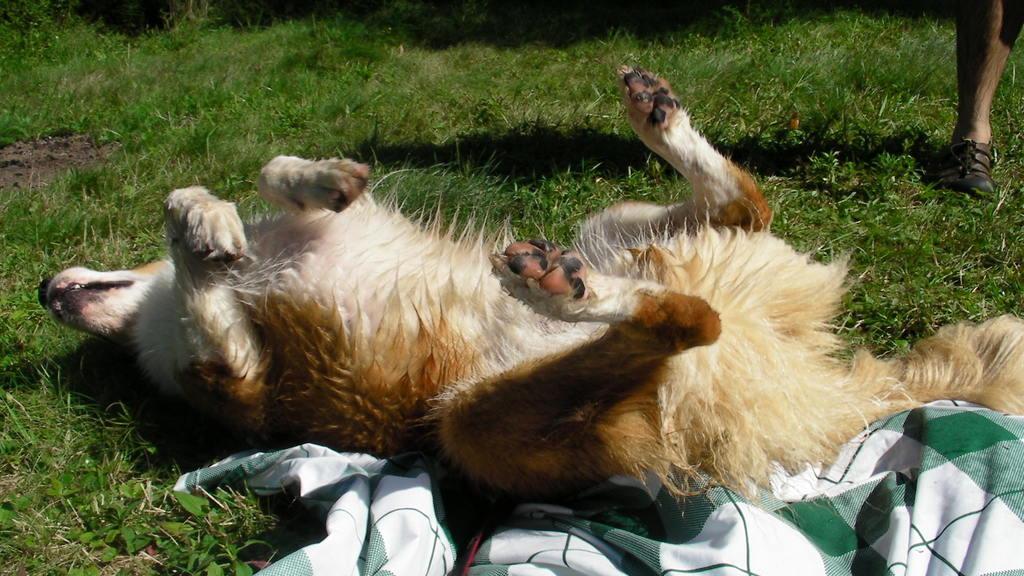In one or two sentences, can you explain what this image depicts? In the image on the ground there is grass. There is a dog lying on the ground. At the bottom of the image there is a cloth. In the top left corner of the image there is a leg with footwear. 